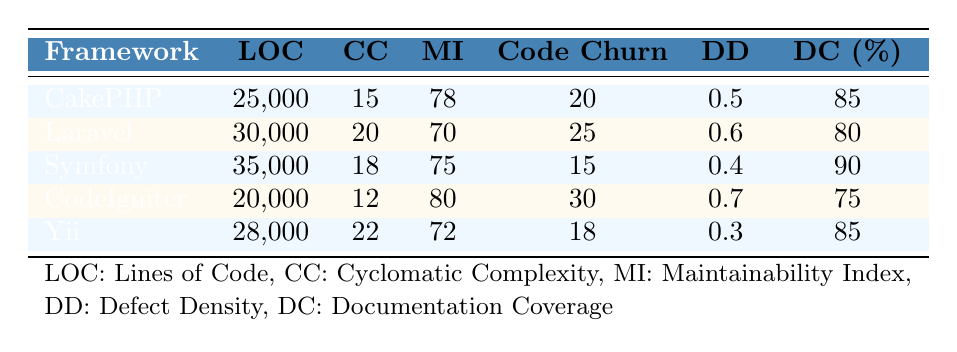What is the lines of code for CakePHP? The table indicates that the lines of code for CakePHP is shown in the "LOC" column. Looking at the row corresponding to CakePHP, the value is 25,000.
Answer: 25,000 Which framework has the highest documentation coverage percentage? To find the highest documentation coverage, we can compare the values in the "DC (%)" column. The values are 85 for CakePHP, 80 for Laravel, 90 for Symfony, 75 for CodeIgniter, and 85 for Yii. The highest value is 90, which corresponds to Symfony.
Answer: Symfony What is the average cyclomatic complexity across all frameworks? To calculate the average cyclomatic complexity, we sum the values from the "CC" column: 15 (CakePHP) + 20 (Laravel) + 18 (Symfony) + 12 (CodeIgniter) + 22 (Yii) = 87. There are 5 frameworks, so to find the average we divide by 5. The average is 87/5 = 17.4.
Answer: 17.4 Is the defect density for CodeIgniter greater than that for Yii? By examining the "DD" column, CodeIgniter has a defect density of 0.7 and Yii has 0.3. Since 0.7 is greater than 0.3, the statement is true.
Answer: Yes Which framework has the lowest maintainability index? Looking at the "MI" column, the values are 78 for CakePHP, 70 for Laravel, 75 for Symfony, 80 for CodeIgniter, and 72 for Yii. The lowest value is 70, which corresponds to Laravel.
Answer: Laravel What is the difference in lines of code between Symfony and CodeIgniter? The lines of code for Symfony is 35,000 and for CodeIgniter it is 20,000. The difference is calculated as 35,000 - 20,000 = 15,000.
Answer: 15,000 Do both CakePHP and Yii frameworks have the same documentation coverage percentage? CakePHP has a documentation coverage percentage of 85 and Yii also has 85. Since these values are equal, the statement is true.
Answer: Yes Which framework has the best maintainability index and what is its value? The "MI" column reveals the following values: 78 for CakePHP, 70 for Laravel, 75 for Symfony, 80 for CodeIgniter, and 72 for Yii. The highest value is 80 for CodeIgniter, meaning it has the best maintainability index.
Answer: CodeIgniter, 80 What framework has the lowest code churn percentage? The "Code Churn" column values are 20 for CakePHP, 25 for Laravel, 15 for Symfony, 30 for CodeIgniter, and 18 for Yii. The lowest value is 15, which corresponds to Symfony.
Answer: Symfony 